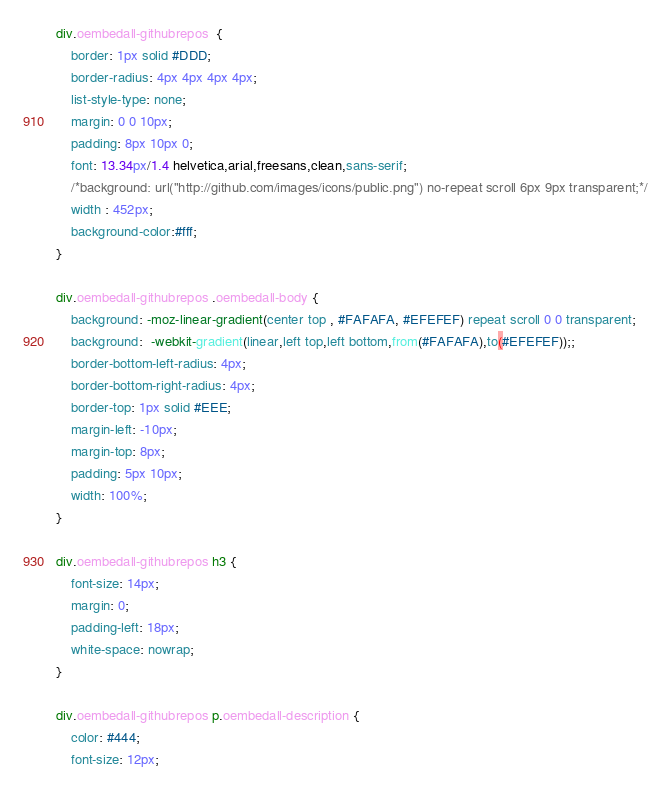<code> <loc_0><loc_0><loc_500><loc_500><_CSS_>div.oembedall-githubrepos  {
    border: 1px solid #DDD;
    border-radius: 4px 4px 4px 4px;
    list-style-type: none;
    margin: 0 0 10px;
    padding: 8px 10px 0;
    font: 13.34px/1.4 helvetica,arial,freesans,clean,sans-serif;
    /*background: url("http://github.com/images/icons/public.png") no-repeat scroll 6px 9px transparent;*/
    width : 452px;
    background-color:#fff;
}

div.oembedall-githubrepos .oembedall-body {
    background: -moz-linear-gradient(center top , #FAFAFA, #EFEFEF) repeat scroll 0 0 transparent;
    background:  -webkit-gradient(linear,left top,left bottom,from(#FAFAFA),to(#EFEFEF));;
    border-bottom-left-radius: 4px;
    border-bottom-right-radius: 4px;
    border-top: 1px solid #EEE;
    margin-left: -10px;
    margin-top: 8px;
    padding: 5px 10px;
    width: 100%;
}

div.oembedall-githubrepos h3 {
    font-size: 14px;
    margin: 0;
    padding-left: 18px;
    white-space: nowrap;
}

div.oembedall-githubrepos p.oembedall-description {
    color: #444;
    font-size: 12px;</code> 